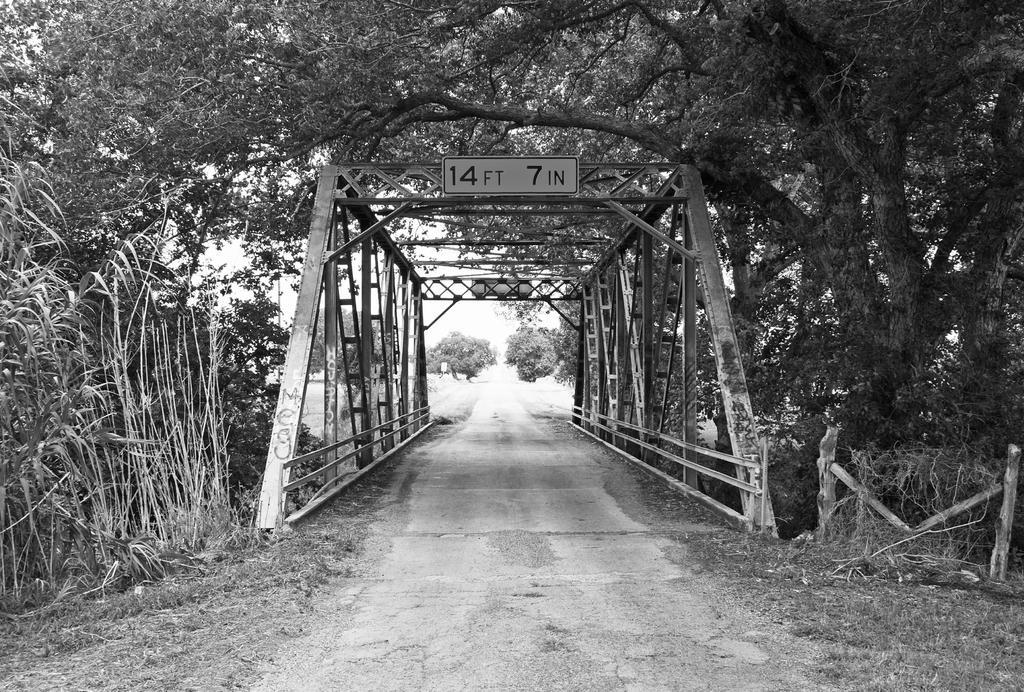In one or two sentences, can you explain what this image depicts? It is the black and white image in which there is a bridge in the middle. There are trees around the bridge. At the top of the bridge there is a board. On the ground there is grass. In the middle there is a way. 